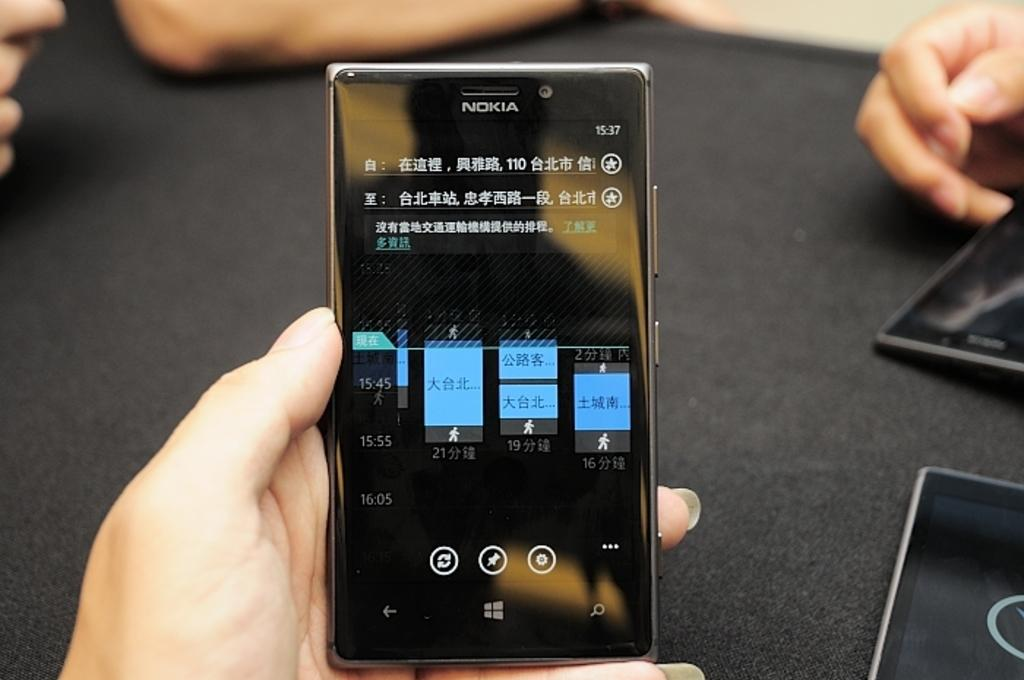<image>
Share a concise interpretation of the image provided. Nokia phone screen that has some chinese letters on it. 